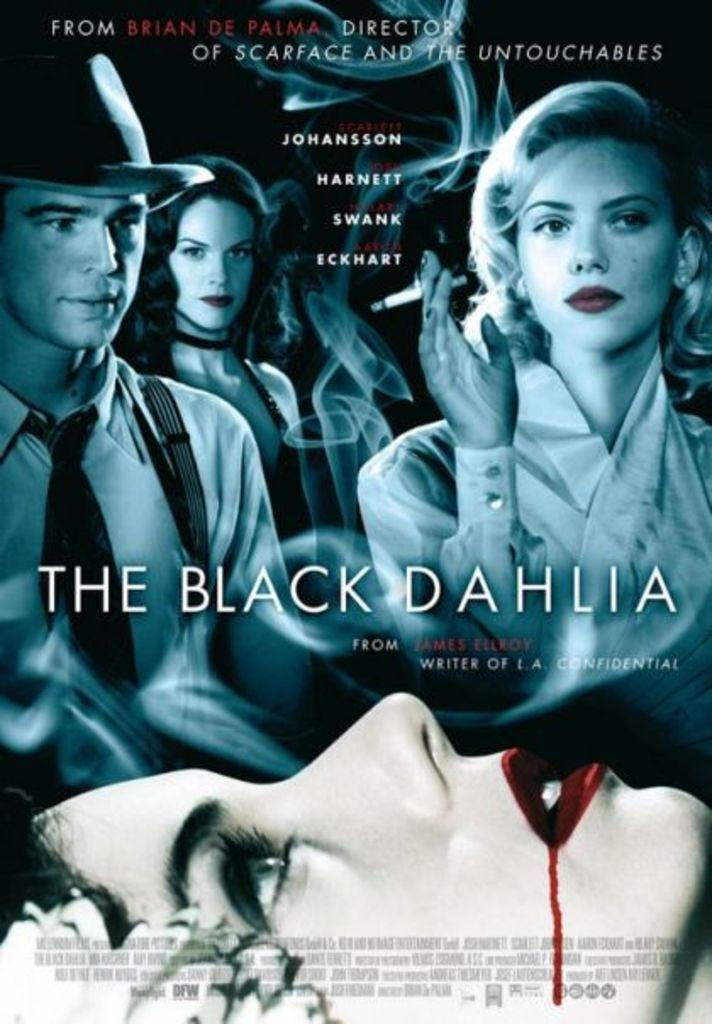<image>
Write a terse but informative summary of the picture. A movie poster advertising "The Black Dahlia" shows a list of actors. 